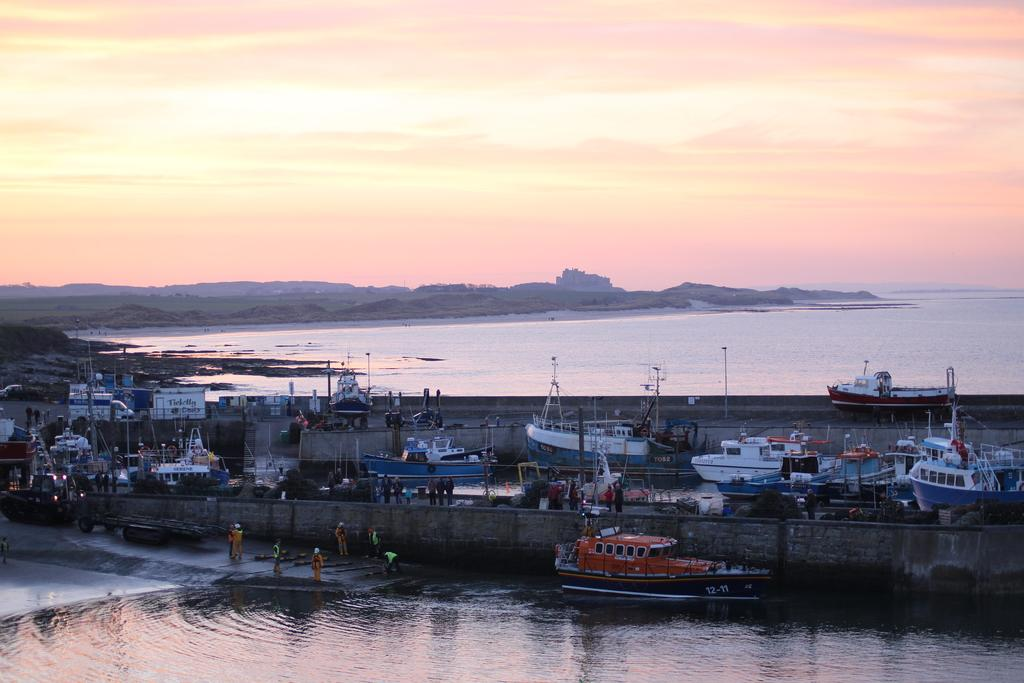What is the primary element in the image? There is a water surface in the image. What can be seen in the background of the image? There are trees visible in the background of the image. What type of vehicles are present in the image? There are boats in the image. What is visible in the sky in the image? Clouds are present in the sky in the image. What is the weight of the attempt made by the design in the image? There is no attempt or design present in the image; it features a water surface, trees, boats, and clouds. 